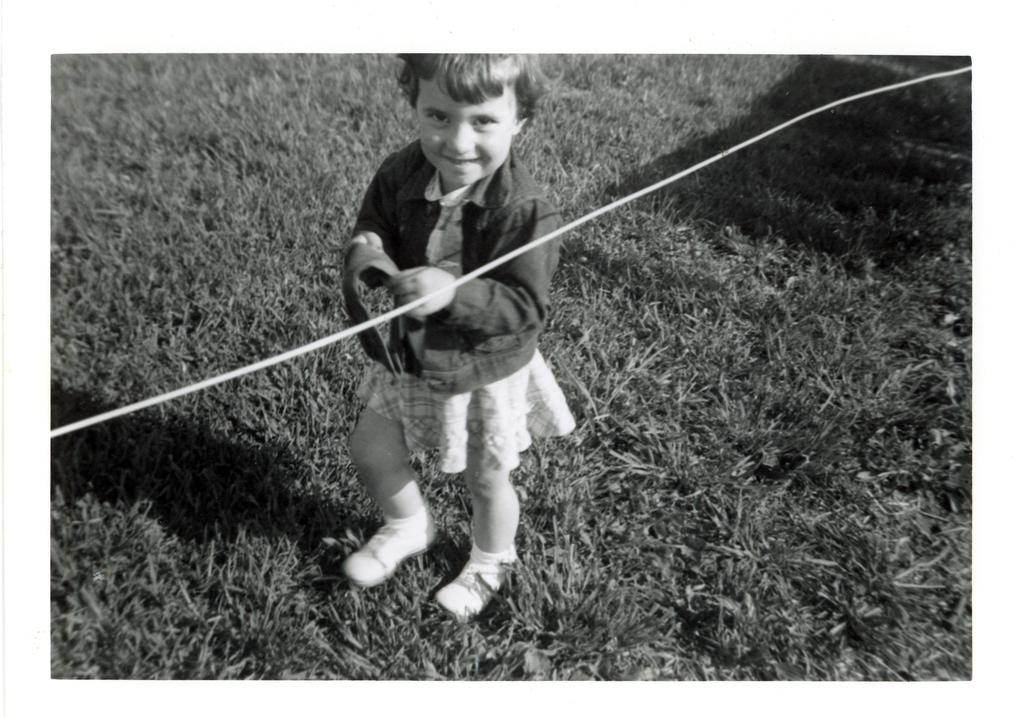What is the color scheme of the image? The image is black and white. What is the kid doing in the image? The kid is holding an object in the image. What can be seen in the background of the image? There is a wire in the image. What type of terrain is visible at the bottom of the image? There is grass at the bottom of the image. What type of gate can be seen in the image? There is no gate present in the image. Is the grass covered in sleet in the image? The image is black and white, and there is no indication of sleet or any other weather condition affecting the grass. 